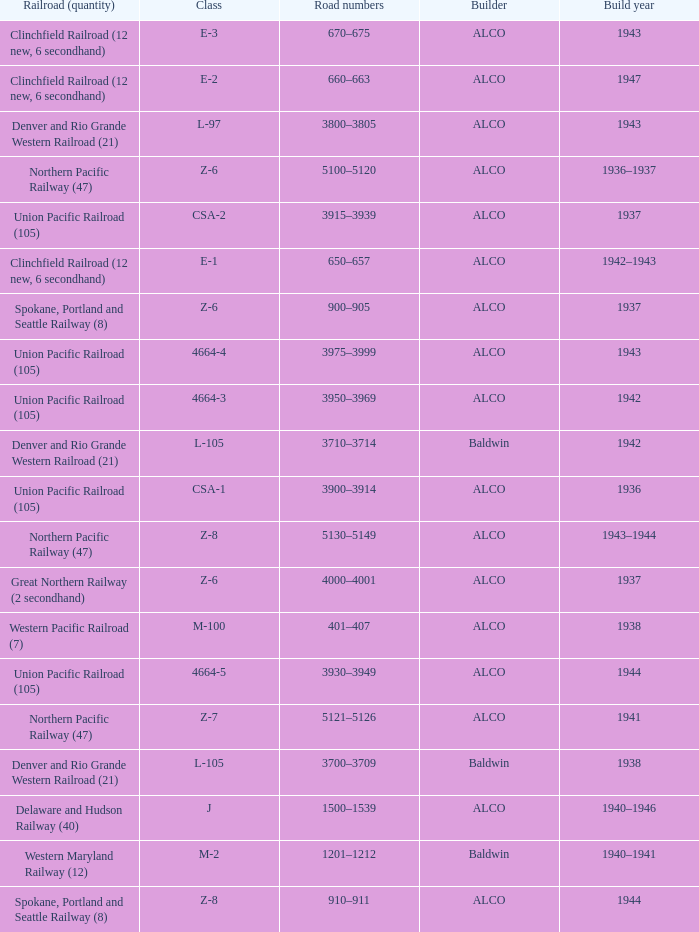What is the road numbers when the build year is 1943, the railroad (quantity) is clinchfield railroad (12 new, 6 secondhand)? 670–675. 